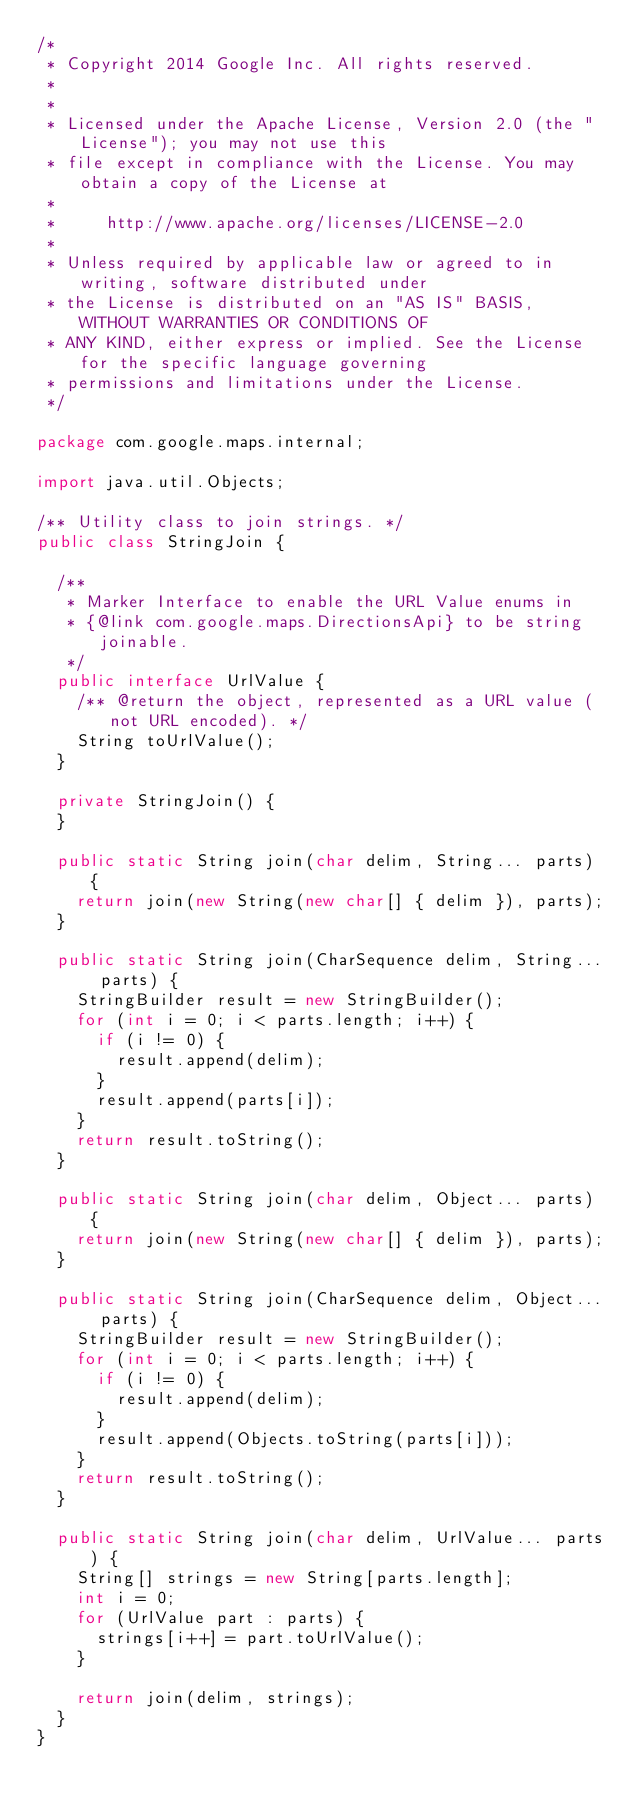Convert code to text. <code><loc_0><loc_0><loc_500><loc_500><_Java_>/*
 * Copyright 2014 Google Inc. All rights reserved.
 *
 *
 * Licensed under the Apache License, Version 2.0 (the "License"); you may not use this
 * file except in compliance with the License. You may obtain a copy of the License at
 *
 *     http://www.apache.org/licenses/LICENSE-2.0
 *
 * Unless required by applicable law or agreed to in writing, software distributed under
 * the License is distributed on an "AS IS" BASIS, WITHOUT WARRANTIES OR CONDITIONS OF
 * ANY KIND, either express or implied. See the License for the specific language governing
 * permissions and limitations under the License.
 */

package com.google.maps.internal;

import java.util.Objects;

/** Utility class to join strings. */
public class StringJoin {

	/**
	 * Marker Interface to enable the URL Value enums in
	 * {@link com.google.maps.DirectionsApi} to be string joinable.
	 */
	public interface UrlValue {
		/** @return the object, represented as a URL value (not URL encoded). */
		String toUrlValue();
	}

	private StringJoin() {
	}

	public static String join(char delim, String... parts) {
		return join(new String(new char[] { delim }), parts);
	}

	public static String join(CharSequence delim, String... parts) {
		StringBuilder result = new StringBuilder();
		for (int i = 0; i < parts.length; i++) {
			if (i != 0) {
				result.append(delim);
			}
			result.append(parts[i]);
		}
		return result.toString();
	}

	public static String join(char delim, Object... parts) {
		return join(new String(new char[] { delim }), parts);
	}

	public static String join(CharSequence delim, Object... parts) {
		StringBuilder result = new StringBuilder();
		for (int i = 0; i < parts.length; i++) {
			if (i != 0) {
				result.append(delim);
			}
			result.append(Objects.toString(parts[i]));
		}
		return result.toString();
	}

	public static String join(char delim, UrlValue... parts) {
		String[] strings = new String[parts.length];
		int i = 0;
		for (UrlValue part : parts) {
			strings[i++] = part.toUrlValue();
		}

		return join(delim, strings);
	}
}
</code> 